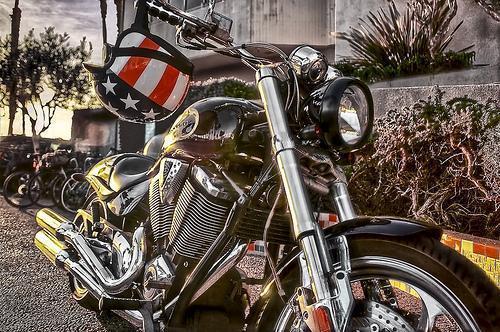How many wheels does the motorcycle have?
Give a very brief answer. 2. How many trees are in the background?
Give a very brief answer. 1. How many bikes have a helmet attached to the handlebar?
Give a very brief answer. 1. 